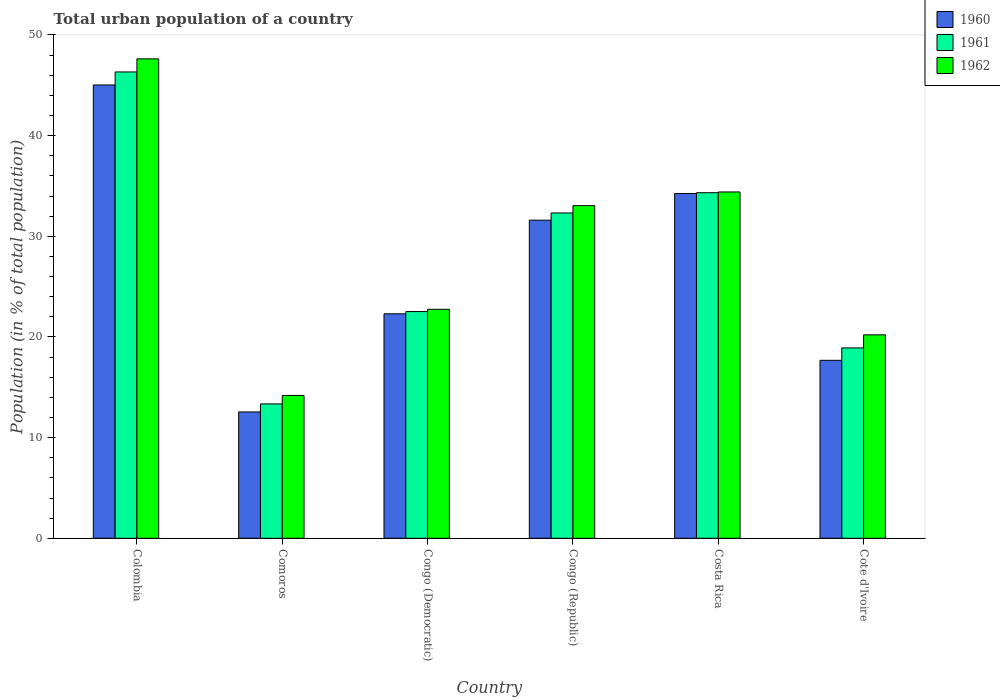How many groups of bars are there?
Make the answer very short. 6. Are the number of bars on each tick of the X-axis equal?
Your response must be concise. Yes. How many bars are there on the 1st tick from the left?
Provide a succinct answer. 3. How many bars are there on the 4th tick from the right?
Give a very brief answer. 3. What is the label of the 6th group of bars from the left?
Keep it short and to the point. Cote d'Ivoire. In how many cases, is the number of bars for a given country not equal to the number of legend labels?
Ensure brevity in your answer.  0. What is the urban population in 1962 in Congo (Democratic)?
Keep it short and to the point. 22.75. Across all countries, what is the maximum urban population in 1962?
Ensure brevity in your answer.  47.63. Across all countries, what is the minimum urban population in 1961?
Make the answer very short. 13.35. In which country was the urban population in 1962 maximum?
Provide a succinct answer. Colombia. In which country was the urban population in 1960 minimum?
Make the answer very short. Comoros. What is the total urban population in 1960 in the graph?
Your response must be concise. 163.42. What is the difference between the urban population in 1961 in Colombia and that in Congo (Democratic)?
Provide a succinct answer. 23.8. What is the difference between the urban population in 1961 in Congo (Democratic) and the urban population in 1962 in Congo (Republic)?
Make the answer very short. -10.52. What is the average urban population in 1960 per country?
Ensure brevity in your answer.  27.24. What is the difference between the urban population of/in 1962 and urban population of/in 1961 in Comoros?
Offer a very short reply. 0.84. In how many countries, is the urban population in 1960 greater than 46 %?
Your answer should be very brief. 0. What is the ratio of the urban population in 1961 in Costa Rica to that in Cote d'Ivoire?
Offer a terse response. 1.82. Is the difference between the urban population in 1962 in Costa Rica and Cote d'Ivoire greater than the difference between the urban population in 1961 in Costa Rica and Cote d'Ivoire?
Provide a succinct answer. No. What is the difference between the highest and the second highest urban population in 1961?
Provide a short and direct response. -2.01. What is the difference between the highest and the lowest urban population in 1961?
Provide a short and direct response. 32.98. In how many countries, is the urban population in 1960 greater than the average urban population in 1960 taken over all countries?
Provide a short and direct response. 3. What does the 1st bar from the left in Comoros represents?
Give a very brief answer. 1960. What does the 2nd bar from the right in Costa Rica represents?
Your answer should be compact. 1961. Are all the bars in the graph horizontal?
Your answer should be compact. No. Are the values on the major ticks of Y-axis written in scientific E-notation?
Provide a short and direct response. No. Does the graph contain grids?
Make the answer very short. No. Where does the legend appear in the graph?
Ensure brevity in your answer.  Top right. How many legend labels are there?
Your answer should be very brief. 3. How are the legend labels stacked?
Your answer should be very brief. Vertical. What is the title of the graph?
Provide a succinct answer. Total urban population of a country. Does "1996" appear as one of the legend labels in the graph?
Provide a succinct answer. No. What is the label or title of the X-axis?
Keep it short and to the point. Country. What is the label or title of the Y-axis?
Your answer should be very brief. Population (in % of total population). What is the Population (in % of total population) of 1960 in Colombia?
Keep it short and to the point. 45.03. What is the Population (in % of total population) in 1961 in Colombia?
Your response must be concise. 46.33. What is the Population (in % of total population) of 1962 in Colombia?
Your answer should be very brief. 47.63. What is the Population (in % of total population) in 1960 in Comoros?
Keep it short and to the point. 12.55. What is the Population (in % of total population) of 1961 in Comoros?
Provide a short and direct response. 13.35. What is the Population (in % of total population) of 1962 in Comoros?
Make the answer very short. 14.19. What is the Population (in % of total population) in 1960 in Congo (Democratic)?
Your response must be concise. 22.3. What is the Population (in % of total population) of 1961 in Congo (Democratic)?
Offer a terse response. 22.52. What is the Population (in % of total population) of 1962 in Congo (Democratic)?
Ensure brevity in your answer.  22.75. What is the Population (in % of total population) in 1960 in Congo (Republic)?
Provide a short and direct response. 31.6. What is the Population (in % of total population) in 1961 in Congo (Republic)?
Your answer should be compact. 32.32. What is the Population (in % of total population) in 1962 in Congo (Republic)?
Your response must be concise. 33.05. What is the Population (in % of total population) of 1960 in Costa Rica?
Keep it short and to the point. 34.25. What is the Population (in % of total population) of 1961 in Costa Rica?
Your response must be concise. 34.33. What is the Population (in % of total population) in 1962 in Costa Rica?
Give a very brief answer. 34.4. What is the Population (in % of total population) in 1960 in Cote d'Ivoire?
Offer a very short reply. 17.68. What is the Population (in % of total population) of 1961 in Cote d'Ivoire?
Your response must be concise. 18.91. What is the Population (in % of total population) in 1962 in Cote d'Ivoire?
Provide a short and direct response. 20.21. Across all countries, what is the maximum Population (in % of total population) of 1960?
Give a very brief answer. 45.03. Across all countries, what is the maximum Population (in % of total population) of 1961?
Offer a very short reply. 46.33. Across all countries, what is the maximum Population (in % of total population) in 1962?
Make the answer very short. 47.63. Across all countries, what is the minimum Population (in % of total population) of 1960?
Your response must be concise. 12.55. Across all countries, what is the minimum Population (in % of total population) of 1961?
Provide a succinct answer. 13.35. Across all countries, what is the minimum Population (in % of total population) of 1962?
Provide a short and direct response. 14.19. What is the total Population (in % of total population) of 1960 in the graph?
Your response must be concise. 163.42. What is the total Population (in % of total population) in 1961 in the graph?
Your response must be concise. 167.76. What is the total Population (in % of total population) in 1962 in the graph?
Your answer should be compact. 172.22. What is the difference between the Population (in % of total population) of 1960 in Colombia and that in Comoros?
Provide a succinct answer. 32.48. What is the difference between the Population (in % of total population) in 1961 in Colombia and that in Comoros?
Keep it short and to the point. 32.98. What is the difference between the Population (in % of total population) of 1962 in Colombia and that in Comoros?
Keep it short and to the point. 33.44. What is the difference between the Population (in % of total population) in 1960 in Colombia and that in Congo (Democratic)?
Your answer should be compact. 22.73. What is the difference between the Population (in % of total population) in 1961 in Colombia and that in Congo (Democratic)?
Your response must be concise. 23.8. What is the difference between the Population (in % of total population) in 1962 in Colombia and that in Congo (Democratic)?
Your response must be concise. 24.88. What is the difference between the Population (in % of total population) of 1960 in Colombia and that in Congo (Republic)?
Your response must be concise. 13.43. What is the difference between the Population (in % of total population) in 1961 in Colombia and that in Congo (Republic)?
Ensure brevity in your answer.  14.01. What is the difference between the Population (in % of total population) in 1962 in Colombia and that in Congo (Republic)?
Keep it short and to the point. 14.58. What is the difference between the Population (in % of total population) in 1960 in Colombia and that in Costa Rica?
Provide a succinct answer. 10.78. What is the difference between the Population (in % of total population) in 1961 in Colombia and that in Costa Rica?
Offer a terse response. 12. What is the difference between the Population (in % of total population) in 1962 in Colombia and that in Costa Rica?
Make the answer very short. 13.22. What is the difference between the Population (in % of total population) in 1960 in Colombia and that in Cote d'Ivoire?
Your answer should be compact. 27.35. What is the difference between the Population (in % of total population) of 1961 in Colombia and that in Cote d'Ivoire?
Your answer should be compact. 27.42. What is the difference between the Population (in % of total population) of 1962 in Colombia and that in Cote d'Ivoire?
Offer a terse response. 27.42. What is the difference between the Population (in % of total population) of 1960 in Comoros and that in Congo (Democratic)?
Provide a succinct answer. -9.75. What is the difference between the Population (in % of total population) of 1961 in Comoros and that in Congo (Democratic)?
Provide a short and direct response. -9.18. What is the difference between the Population (in % of total population) in 1962 in Comoros and that in Congo (Democratic)?
Keep it short and to the point. -8.56. What is the difference between the Population (in % of total population) in 1960 in Comoros and that in Congo (Republic)?
Give a very brief answer. -19.05. What is the difference between the Population (in % of total population) of 1961 in Comoros and that in Congo (Republic)?
Make the answer very short. -18.97. What is the difference between the Population (in % of total population) of 1962 in Comoros and that in Congo (Republic)?
Your response must be concise. -18.86. What is the difference between the Population (in % of total population) of 1960 in Comoros and that in Costa Rica?
Give a very brief answer. -21.7. What is the difference between the Population (in % of total population) in 1961 in Comoros and that in Costa Rica?
Your answer should be very brief. -20.98. What is the difference between the Population (in % of total population) in 1962 in Comoros and that in Costa Rica?
Your response must be concise. -20.21. What is the difference between the Population (in % of total population) of 1960 in Comoros and that in Cote d'Ivoire?
Make the answer very short. -5.13. What is the difference between the Population (in % of total population) of 1961 in Comoros and that in Cote d'Ivoire?
Offer a terse response. -5.56. What is the difference between the Population (in % of total population) of 1962 in Comoros and that in Cote d'Ivoire?
Provide a succinct answer. -6.02. What is the difference between the Population (in % of total population) of 1960 in Congo (Democratic) and that in Congo (Republic)?
Give a very brief answer. -9.3. What is the difference between the Population (in % of total population) of 1961 in Congo (Democratic) and that in Congo (Republic)?
Provide a short and direct response. -9.79. What is the difference between the Population (in % of total population) of 1962 in Congo (Democratic) and that in Congo (Republic)?
Keep it short and to the point. -10.3. What is the difference between the Population (in % of total population) in 1960 in Congo (Democratic) and that in Costa Rica?
Your response must be concise. -11.95. What is the difference between the Population (in % of total population) of 1961 in Congo (Democratic) and that in Costa Rica?
Ensure brevity in your answer.  -11.81. What is the difference between the Population (in % of total population) in 1962 in Congo (Democratic) and that in Costa Rica?
Offer a very short reply. -11.65. What is the difference between the Population (in % of total population) of 1960 in Congo (Democratic) and that in Cote d'Ivoire?
Keep it short and to the point. 4.62. What is the difference between the Population (in % of total population) of 1961 in Congo (Democratic) and that in Cote d'Ivoire?
Give a very brief answer. 3.61. What is the difference between the Population (in % of total population) of 1962 in Congo (Democratic) and that in Cote d'Ivoire?
Offer a very short reply. 2.54. What is the difference between the Population (in % of total population) of 1960 in Congo (Republic) and that in Costa Rica?
Your answer should be compact. -2.65. What is the difference between the Population (in % of total population) in 1961 in Congo (Republic) and that in Costa Rica?
Ensure brevity in your answer.  -2.01. What is the difference between the Population (in % of total population) of 1962 in Congo (Republic) and that in Costa Rica?
Ensure brevity in your answer.  -1.36. What is the difference between the Population (in % of total population) in 1960 in Congo (Republic) and that in Cote d'Ivoire?
Your response must be concise. 13.92. What is the difference between the Population (in % of total population) in 1961 in Congo (Republic) and that in Cote d'Ivoire?
Offer a very short reply. 13.41. What is the difference between the Population (in % of total population) of 1962 in Congo (Republic) and that in Cote d'Ivoire?
Give a very brief answer. 12.84. What is the difference between the Population (in % of total population) in 1960 in Costa Rica and that in Cote d'Ivoire?
Provide a short and direct response. 16.57. What is the difference between the Population (in % of total population) of 1961 in Costa Rica and that in Cote d'Ivoire?
Provide a short and direct response. 15.42. What is the difference between the Population (in % of total population) in 1962 in Costa Rica and that in Cote d'Ivoire?
Make the answer very short. 14.19. What is the difference between the Population (in % of total population) of 1960 in Colombia and the Population (in % of total population) of 1961 in Comoros?
Offer a very short reply. 31.68. What is the difference between the Population (in % of total population) of 1960 in Colombia and the Population (in % of total population) of 1962 in Comoros?
Offer a terse response. 30.84. What is the difference between the Population (in % of total population) in 1961 in Colombia and the Population (in % of total population) in 1962 in Comoros?
Offer a very short reply. 32.14. What is the difference between the Population (in % of total population) in 1960 in Colombia and the Population (in % of total population) in 1961 in Congo (Democratic)?
Ensure brevity in your answer.  22.51. What is the difference between the Population (in % of total population) in 1960 in Colombia and the Population (in % of total population) in 1962 in Congo (Democratic)?
Your answer should be compact. 22.28. What is the difference between the Population (in % of total population) of 1961 in Colombia and the Population (in % of total population) of 1962 in Congo (Democratic)?
Keep it short and to the point. 23.58. What is the difference between the Population (in % of total population) of 1960 in Colombia and the Population (in % of total population) of 1961 in Congo (Republic)?
Provide a succinct answer. 12.71. What is the difference between the Population (in % of total population) in 1960 in Colombia and the Population (in % of total population) in 1962 in Congo (Republic)?
Your response must be concise. 11.99. What is the difference between the Population (in % of total population) of 1961 in Colombia and the Population (in % of total population) of 1962 in Congo (Republic)?
Provide a short and direct response. 13.28. What is the difference between the Population (in % of total population) in 1960 in Colombia and the Population (in % of total population) in 1961 in Costa Rica?
Your answer should be very brief. 10.7. What is the difference between the Population (in % of total population) in 1960 in Colombia and the Population (in % of total population) in 1962 in Costa Rica?
Provide a succinct answer. 10.63. What is the difference between the Population (in % of total population) of 1961 in Colombia and the Population (in % of total population) of 1962 in Costa Rica?
Your answer should be compact. 11.92. What is the difference between the Population (in % of total population) in 1960 in Colombia and the Population (in % of total population) in 1961 in Cote d'Ivoire?
Your answer should be compact. 26.12. What is the difference between the Population (in % of total population) of 1960 in Colombia and the Population (in % of total population) of 1962 in Cote d'Ivoire?
Your answer should be compact. 24.82. What is the difference between the Population (in % of total population) in 1961 in Colombia and the Population (in % of total population) in 1962 in Cote d'Ivoire?
Ensure brevity in your answer.  26.12. What is the difference between the Population (in % of total population) of 1960 in Comoros and the Population (in % of total population) of 1961 in Congo (Democratic)?
Ensure brevity in your answer.  -9.97. What is the difference between the Population (in % of total population) of 1960 in Comoros and the Population (in % of total population) of 1962 in Congo (Democratic)?
Make the answer very short. -10.2. What is the difference between the Population (in % of total population) in 1961 in Comoros and the Population (in % of total population) in 1962 in Congo (Democratic)?
Make the answer very short. -9.4. What is the difference between the Population (in % of total population) in 1960 in Comoros and the Population (in % of total population) in 1961 in Congo (Republic)?
Your response must be concise. -19.77. What is the difference between the Population (in % of total population) of 1960 in Comoros and the Population (in % of total population) of 1962 in Congo (Republic)?
Provide a succinct answer. -20.49. What is the difference between the Population (in % of total population) in 1961 in Comoros and the Population (in % of total population) in 1962 in Congo (Republic)?
Provide a short and direct response. -19.7. What is the difference between the Population (in % of total population) in 1960 in Comoros and the Population (in % of total population) in 1961 in Costa Rica?
Give a very brief answer. -21.78. What is the difference between the Population (in % of total population) of 1960 in Comoros and the Population (in % of total population) of 1962 in Costa Rica?
Provide a succinct answer. -21.85. What is the difference between the Population (in % of total population) in 1961 in Comoros and the Population (in % of total population) in 1962 in Costa Rica?
Provide a short and direct response. -21.06. What is the difference between the Population (in % of total population) of 1960 in Comoros and the Population (in % of total population) of 1961 in Cote d'Ivoire?
Your response must be concise. -6.36. What is the difference between the Population (in % of total population) of 1960 in Comoros and the Population (in % of total population) of 1962 in Cote d'Ivoire?
Your answer should be compact. -7.66. What is the difference between the Population (in % of total population) in 1961 in Comoros and the Population (in % of total population) in 1962 in Cote d'Ivoire?
Offer a very short reply. -6.86. What is the difference between the Population (in % of total population) of 1960 in Congo (Democratic) and the Population (in % of total population) of 1961 in Congo (Republic)?
Give a very brief answer. -10.02. What is the difference between the Population (in % of total population) of 1960 in Congo (Democratic) and the Population (in % of total population) of 1962 in Congo (Republic)?
Your answer should be very brief. -10.74. What is the difference between the Population (in % of total population) of 1961 in Congo (Democratic) and the Population (in % of total population) of 1962 in Congo (Republic)?
Your answer should be compact. -10.52. What is the difference between the Population (in % of total population) of 1960 in Congo (Democratic) and the Population (in % of total population) of 1961 in Costa Rica?
Your answer should be compact. -12.03. What is the difference between the Population (in % of total population) of 1960 in Congo (Democratic) and the Population (in % of total population) of 1962 in Costa Rica?
Your answer should be compact. -12.1. What is the difference between the Population (in % of total population) of 1961 in Congo (Democratic) and the Population (in % of total population) of 1962 in Costa Rica?
Your answer should be compact. -11.88. What is the difference between the Population (in % of total population) of 1960 in Congo (Democratic) and the Population (in % of total population) of 1961 in Cote d'Ivoire?
Offer a terse response. 3.39. What is the difference between the Population (in % of total population) of 1960 in Congo (Democratic) and the Population (in % of total population) of 1962 in Cote d'Ivoire?
Ensure brevity in your answer.  2.09. What is the difference between the Population (in % of total population) of 1961 in Congo (Democratic) and the Population (in % of total population) of 1962 in Cote d'Ivoire?
Offer a terse response. 2.31. What is the difference between the Population (in % of total population) of 1960 in Congo (Republic) and the Population (in % of total population) of 1961 in Costa Rica?
Make the answer very short. -2.73. What is the difference between the Population (in % of total population) in 1960 in Congo (Republic) and the Population (in % of total population) in 1962 in Costa Rica?
Keep it short and to the point. -2.8. What is the difference between the Population (in % of total population) of 1961 in Congo (Republic) and the Population (in % of total population) of 1962 in Costa Rica?
Offer a very short reply. -2.09. What is the difference between the Population (in % of total population) of 1960 in Congo (Republic) and the Population (in % of total population) of 1961 in Cote d'Ivoire?
Provide a succinct answer. 12.69. What is the difference between the Population (in % of total population) of 1960 in Congo (Republic) and the Population (in % of total population) of 1962 in Cote d'Ivoire?
Provide a short and direct response. 11.39. What is the difference between the Population (in % of total population) in 1961 in Congo (Republic) and the Population (in % of total population) in 1962 in Cote d'Ivoire?
Make the answer very short. 12.11. What is the difference between the Population (in % of total population) of 1960 in Costa Rica and the Population (in % of total population) of 1961 in Cote d'Ivoire?
Your answer should be very brief. 15.34. What is the difference between the Population (in % of total population) in 1960 in Costa Rica and the Population (in % of total population) in 1962 in Cote d'Ivoire?
Offer a terse response. 14.04. What is the difference between the Population (in % of total population) of 1961 in Costa Rica and the Population (in % of total population) of 1962 in Cote d'Ivoire?
Keep it short and to the point. 14.12. What is the average Population (in % of total population) in 1960 per country?
Make the answer very short. 27.24. What is the average Population (in % of total population) of 1961 per country?
Provide a succinct answer. 27.96. What is the average Population (in % of total population) in 1962 per country?
Make the answer very short. 28.7. What is the difference between the Population (in % of total population) of 1960 and Population (in % of total population) of 1961 in Colombia?
Offer a very short reply. -1.29. What is the difference between the Population (in % of total population) of 1960 and Population (in % of total population) of 1962 in Colombia?
Provide a short and direct response. -2.6. What is the difference between the Population (in % of total population) in 1961 and Population (in % of total population) in 1962 in Colombia?
Provide a short and direct response. -1.3. What is the difference between the Population (in % of total population) of 1960 and Population (in % of total population) of 1961 in Comoros?
Offer a very short reply. -0.8. What is the difference between the Population (in % of total population) in 1960 and Population (in % of total population) in 1962 in Comoros?
Provide a short and direct response. -1.64. What is the difference between the Population (in % of total population) of 1961 and Population (in % of total population) of 1962 in Comoros?
Give a very brief answer. -0.84. What is the difference between the Population (in % of total population) in 1960 and Population (in % of total population) in 1961 in Congo (Democratic)?
Make the answer very short. -0.22. What is the difference between the Population (in % of total population) in 1960 and Population (in % of total population) in 1962 in Congo (Democratic)?
Your response must be concise. -0.45. What is the difference between the Population (in % of total population) of 1961 and Population (in % of total population) of 1962 in Congo (Democratic)?
Keep it short and to the point. -0.23. What is the difference between the Population (in % of total population) of 1960 and Population (in % of total population) of 1961 in Congo (Republic)?
Provide a succinct answer. -0.72. What is the difference between the Population (in % of total population) of 1960 and Population (in % of total population) of 1962 in Congo (Republic)?
Your response must be concise. -1.44. What is the difference between the Population (in % of total population) in 1961 and Population (in % of total population) in 1962 in Congo (Republic)?
Offer a terse response. -0.73. What is the difference between the Population (in % of total population) in 1960 and Population (in % of total population) in 1961 in Costa Rica?
Your response must be concise. -0.07. What is the difference between the Population (in % of total population) of 1961 and Population (in % of total population) of 1962 in Costa Rica?
Ensure brevity in your answer.  -0.07. What is the difference between the Population (in % of total population) of 1960 and Population (in % of total population) of 1961 in Cote d'Ivoire?
Provide a succinct answer. -1.23. What is the difference between the Population (in % of total population) of 1960 and Population (in % of total population) of 1962 in Cote d'Ivoire?
Keep it short and to the point. -2.53. What is the difference between the Population (in % of total population) in 1961 and Population (in % of total population) in 1962 in Cote d'Ivoire?
Provide a succinct answer. -1.3. What is the ratio of the Population (in % of total population) in 1960 in Colombia to that in Comoros?
Offer a terse response. 3.59. What is the ratio of the Population (in % of total population) of 1961 in Colombia to that in Comoros?
Offer a terse response. 3.47. What is the ratio of the Population (in % of total population) of 1962 in Colombia to that in Comoros?
Make the answer very short. 3.36. What is the ratio of the Population (in % of total population) in 1960 in Colombia to that in Congo (Democratic)?
Offer a very short reply. 2.02. What is the ratio of the Population (in % of total population) in 1961 in Colombia to that in Congo (Democratic)?
Your answer should be very brief. 2.06. What is the ratio of the Population (in % of total population) of 1962 in Colombia to that in Congo (Democratic)?
Provide a succinct answer. 2.09. What is the ratio of the Population (in % of total population) of 1960 in Colombia to that in Congo (Republic)?
Your answer should be very brief. 1.43. What is the ratio of the Population (in % of total population) of 1961 in Colombia to that in Congo (Republic)?
Offer a very short reply. 1.43. What is the ratio of the Population (in % of total population) of 1962 in Colombia to that in Congo (Republic)?
Keep it short and to the point. 1.44. What is the ratio of the Population (in % of total population) in 1960 in Colombia to that in Costa Rica?
Keep it short and to the point. 1.31. What is the ratio of the Population (in % of total population) of 1961 in Colombia to that in Costa Rica?
Give a very brief answer. 1.35. What is the ratio of the Population (in % of total population) of 1962 in Colombia to that in Costa Rica?
Offer a terse response. 1.38. What is the ratio of the Population (in % of total population) of 1960 in Colombia to that in Cote d'Ivoire?
Give a very brief answer. 2.55. What is the ratio of the Population (in % of total population) of 1961 in Colombia to that in Cote d'Ivoire?
Your response must be concise. 2.45. What is the ratio of the Population (in % of total population) in 1962 in Colombia to that in Cote d'Ivoire?
Provide a short and direct response. 2.36. What is the ratio of the Population (in % of total population) of 1960 in Comoros to that in Congo (Democratic)?
Your answer should be very brief. 0.56. What is the ratio of the Population (in % of total population) in 1961 in Comoros to that in Congo (Democratic)?
Make the answer very short. 0.59. What is the ratio of the Population (in % of total population) in 1962 in Comoros to that in Congo (Democratic)?
Give a very brief answer. 0.62. What is the ratio of the Population (in % of total population) in 1960 in Comoros to that in Congo (Republic)?
Offer a very short reply. 0.4. What is the ratio of the Population (in % of total population) of 1961 in Comoros to that in Congo (Republic)?
Give a very brief answer. 0.41. What is the ratio of the Population (in % of total population) of 1962 in Comoros to that in Congo (Republic)?
Your answer should be compact. 0.43. What is the ratio of the Population (in % of total population) of 1960 in Comoros to that in Costa Rica?
Your answer should be very brief. 0.37. What is the ratio of the Population (in % of total population) of 1961 in Comoros to that in Costa Rica?
Keep it short and to the point. 0.39. What is the ratio of the Population (in % of total population) in 1962 in Comoros to that in Costa Rica?
Make the answer very short. 0.41. What is the ratio of the Population (in % of total population) of 1960 in Comoros to that in Cote d'Ivoire?
Your answer should be compact. 0.71. What is the ratio of the Population (in % of total population) of 1961 in Comoros to that in Cote d'Ivoire?
Offer a very short reply. 0.71. What is the ratio of the Population (in % of total population) in 1962 in Comoros to that in Cote d'Ivoire?
Your answer should be very brief. 0.7. What is the ratio of the Population (in % of total population) of 1960 in Congo (Democratic) to that in Congo (Republic)?
Your answer should be compact. 0.71. What is the ratio of the Population (in % of total population) in 1961 in Congo (Democratic) to that in Congo (Republic)?
Give a very brief answer. 0.7. What is the ratio of the Population (in % of total population) in 1962 in Congo (Democratic) to that in Congo (Republic)?
Ensure brevity in your answer.  0.69. What is the ratio of the Population (in % of total population) of 1960 in Congo (Democratic) to that in Costa Rica?
Offer a terse response. 0.65. What is the ratio of the Population (in % of total population) of 1961 in Congo (Democratic) to that in Costa Rica?
Give a very brief answer. 0.66. What is the ratio of the Population (in % of total population) in 1962 in Congo (Democratic) to that in Costa Rica?
Offer a terse response. 0.66. What is the ratio of the Population (in % of total population) of 1960 in Congo (Democratic) to that in Cote d'Ivoire?
Your answer should be compact. 1.26. What is the ratio of the Population (in % of total population) of 1961 in Congo (Democratic) to that in Cote d'Ivoire?
Provide a short and direct response. 1.19. What is the ratio of the Population (in % of total population) of 1962 in Congo (Democratic) to that in Cote d'Ivoire?
Make the answer very short. 1.13. What is the ratio of the Population (in % of total population) in 1960 in Congo (Republic) to that in Costa Rica?
Keep it short and to the point. 0.92. What is the ratio of the Population (in % of total population) of 1961 in Congo (Republic) to that in Costa Rica?
Your answer should be very brief. 0.94. What is the ratio of the Population (in % of total population) in 1962 in Congo (Republic) to that in Costa Rica?
Offer a terse response. 0.96. What is the ratio of the Population (in % of total population) in 1960 in Congo (Republic) to that in Cote d'Ivoire?
Ensure brevity in your answer.  1.79. What is the ratio of the Population (in % of total population) in 1961 in Congo (Republic) to that in Cote d'Ivoire?
Ensure brevity in your answer.  1.71. What is the ratio of the Population (in % of total population) in 1962 in Congo (Republic) to that in Cote d'Ivoire?
Make the answer very short. 1.64. What is the ratio of the Population (in % of total population) in 1960 in Costa Rica to that in Cote d'Ivoire?
Your response must be concise. 1.94. What is the ratio of the Population (in % of total population) in 1961 in Costa Rica to that in Cote d'Ivoire?
Offer a very short reply. 1.82. What is the ratio of the Population (in % of total population) of 1962 in Costa Rica to that in Cote d'Ivoire?
Provide a short and direct response. 1.7. What is the difference between the highest and the second highest Population (in % of total population) in 1960?
Give a very brief answer. 10.78. What is the difference between the highest and the second highest Population (in % of total population) of 1961?
Ensure brevity in your answer.  12. What is the difference between the highest and the second highest Population (in % of total population) of 1962?
Provide a short and direct response. 13.22. What is the difference between the highest and the lowest Population (in % of total population) of 1960?
Provide a short and direct response. 32.48. What is the difference between the highest and the lowest Population (in % of total population) in 1961?
Provide a succinct answer. 32.98. What is the difference between the highest and the lowest Population (in % of total population) of 1962?
Your response must be concise. 33.44. 